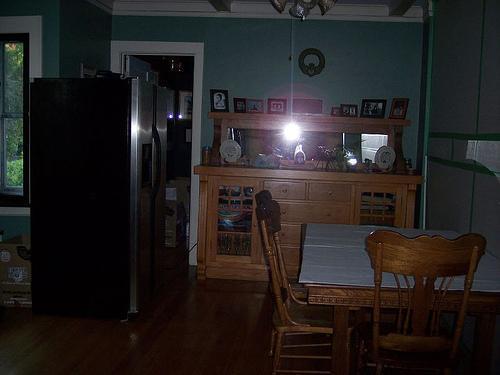How many candles are lit?
Give a very brief answer. 0. How many chairs are present?
Give a very brief answer. 2. How many chairs are in the room?
Give a very brief answer. 2. How many refrigerators can you see?
Give a very brief answer. 2. How many chairs can you see?
Give a very brief answer. 2. 